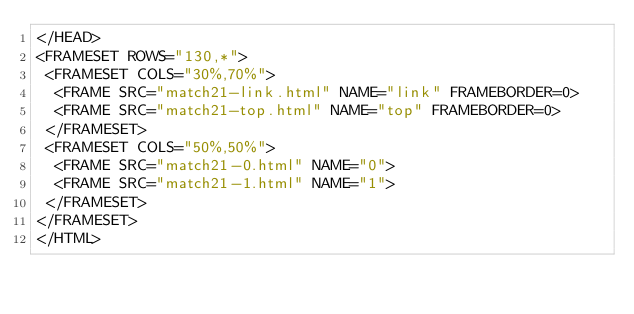<code> <loc_0><loc_0><loc_500><loc_500><_HTML_></HEAD>
<FRAMESET ROWS="130,*">
 <FRAMESET COLS="30%,70%">
  <FRAME SRC="match21-link.html" NAME="link" FRAMEBORDER=0>
  <FRAME SRC="match21-top.html" NAME="top" FRAMEBORDER=0>
 </FRAMESET>
 <FRAMESET COLS="50%,50%">
  <FRAME SRC="match21-0.html" NAME="0">
  <FRAME SRC="match21-1.html" NAME="1">
 </FRAMESET>
</FRAMESET>
</HTML>
</code> 